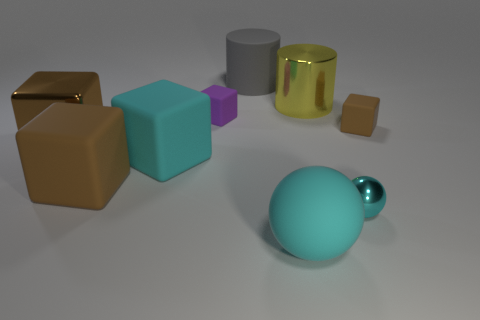Is the number of cubes behind the large gray thing greater than the number of small brown things?
Offer a very short reply. No. What number of big brown things are right of the big yellow object to the right of the gray cylinder?
Keep it short and to the point. 0. There is a large shiny object that is in front of the cube that is behind the rubber object that is on the right side of the tiny metallic ball; what shape is it?
Provide a succinct answer. Cube. The cyan matte block has what size?
Your response must be concise. Large. Are there any small things that have the same material as the small sphere?
Ensure brevity in your answer.  No. What is the size of the cyan rubber object that is the same shape as the small brown object?
Provide a short and direct response. Large. Are there an equal number of small purple objects that are behind the large rubber cylinder and small green rubber blocks?
Provide a succinct answer. Yes. Is the shape of the big rubber thing that is behind the small brown matte thing the same as  the yellow metal thing?
Offer a terse response. Yes. What shape is the tiny metallic thing?
Offer a very short reply. Sphere. What material is the large cylinder that is behind the shiny cylinder behind the big cyan rubber object that is on the right side of the large gray rubber cylinder made of?
Ensure brevity in your answer.  Rubber. 